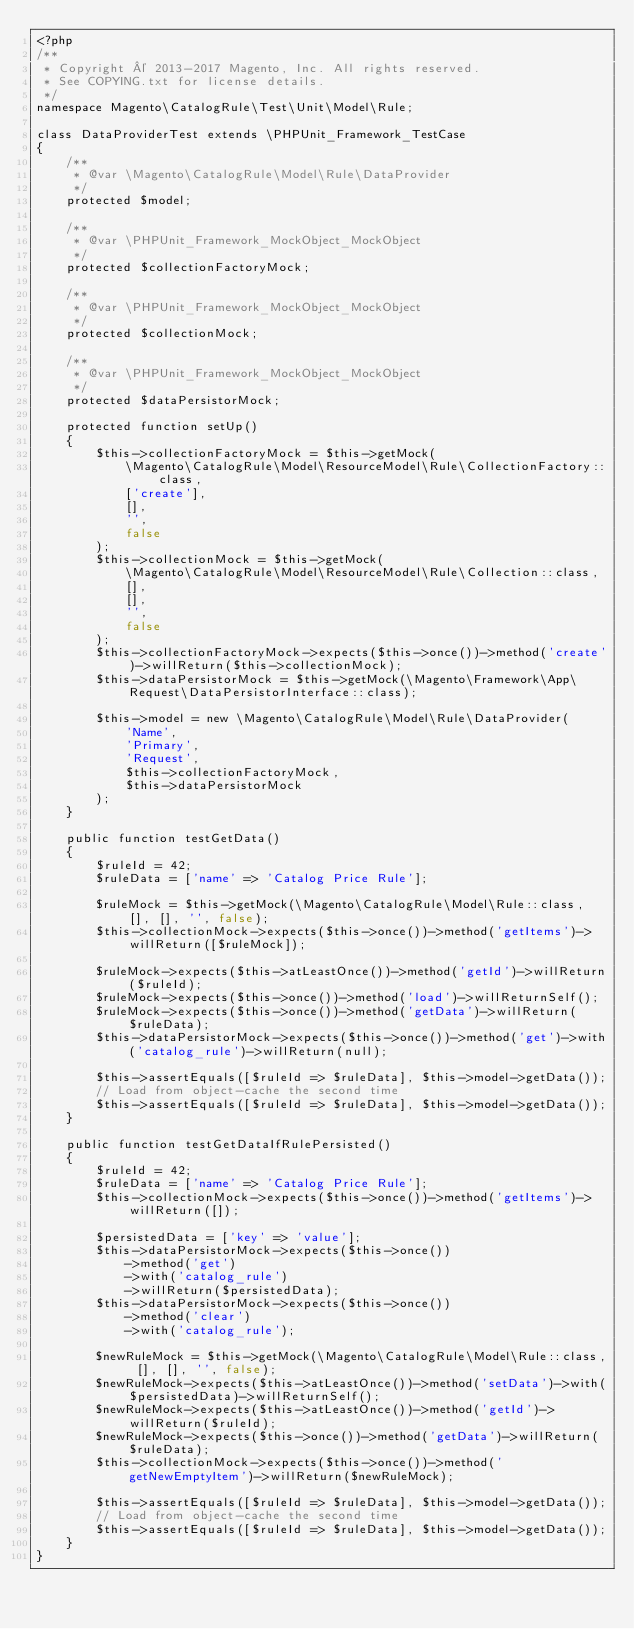Convert code to text. <code><loc_0><loc_0><loc_500><loc_500><_PHP_><?php
/**
 * Copyright © 2013-2017 Magento, Inc. All rights reserved.
 * See COPYING.txt for license details.
 */
namespace Magento\CatalogRule\Test\Unit\Model\Rule;

class DataProviderTest extends \PHPUnit_Framework_TestCase
{
    /**
     * @var \Magento\CatalogRule\Model\Rule\DataProvider
     */
    protected $model;

    /**
     * @var \PHPUnit_Framework_MockObject_MockObject
     */
    protected $collectionFactoryMock;

    /**
     * @var \PHPUnit_Framework_MockObject_MockObject
     */
    protected $collectionMock;

    /**
     * @var \PHPUnit_Framework_MockObject_MockObject
     */
    protected $dataPersistorMock;

    protected function setUp()
    {
        $this->collectionFactoryMock = $this->getMock(
            \Magento\CatalogRule\Model\ResourceModel\Rule\CollectionFactory::class,
            ['create'],
            [],
            '',
            false
        );
        $this->collectionMock = $this->getMock(
            \Magento\CatalogRule\Model\ResourceModel\Rule\Collection::class,
            [],
            [],
            '',
            false
        );
        $this->collectionFactoryMock->expects($this->once())->method('create')->willReturn($this->collectionMock);
        $this->dataPersistorMock = $this->getMock(\Magento\Framework\App\Request\DataPersistorInterface::class);

        $this->model = new \Magento\CatalogRule\Model\Rule\DataProvider(
            'Name',
            'Primary',
            'Request',
            $this->collectionFactoryMock,
            $this->dataPersistorMock
        );
    }

    public function testGetData()
    {
        $ruleId = 42;
        $ruleData = ['name' => 'Catalog Price Rule'];

        $ruleMock = $this->getMock(\Magento\CatalogRule\Model\Rule::class, [], [], '', false);
        $this->collectionMock->expects($this->once())->method('getItems')->willReturn([$ruleMock]);

        $ruleMock->expects($this->atLeastOnce())->method('getId')->willReturn($ruleId);
        $ruleMock->expects($this->once())->method('load')->willReturnSelf();
        $ruleMock->expects($this->once())->method('getData')->willReturn($ruleData);
        $this->dataPersistorMock->expects($this->once())->method('get')->with('catalog_rule')->willReturn(null);

        $this->assertEquals([$ruleId => $ruleData], $this->model->getData());
        // Load from object-cache the second time
        $this->assertEquals([$ruleId => $ruleData], $this->model->getData());
    }

    public function testGetDataIfRulePersisted()
    {
        $ruleId = 42;
        $ruleData = ['name' => 'Catalog Price Rule'];
        $this->collectionMock->expects($this->once())->method('getItems')->willReturn([]);

        $persistedData = ['key' => 'value'];
        $this->dataPersistorMock->expects($this->once())
            ->method('get')
            ->with('catalog_rule')
            ->willReturn($persistedData);
        $this->dataPersistorMock->expects($this->once())
            ->method('clear')
            ->with('catalog_rule');

        $newRuleMock = $this->getMock(\Magento\CatalogRule\Model\Rule::class, [], [], '', false);
        $newRuleMock->expects($this->atLeastOnce())->method('setData')->with($persistedData)->willReturnSelf();
        $newRuleMock->expects($this->atLeastOnce())->method('getId')->willReturn($ruleId);
        $newRuleMock->expects($this->once())->method('getData')->willReturn($ruleData);
        $this->collectionMock->expects($this->once())->method('getNewEmptyItem')->willReturn($newRuleMock);

        $this->assertEquals([$ruleId => $ruleData], $this->model->getData());
        // Load from object-cache the second time
        $this->assertEquals([$ruleId => $ruleData], $this->model->getData());
    }
}
</code> 